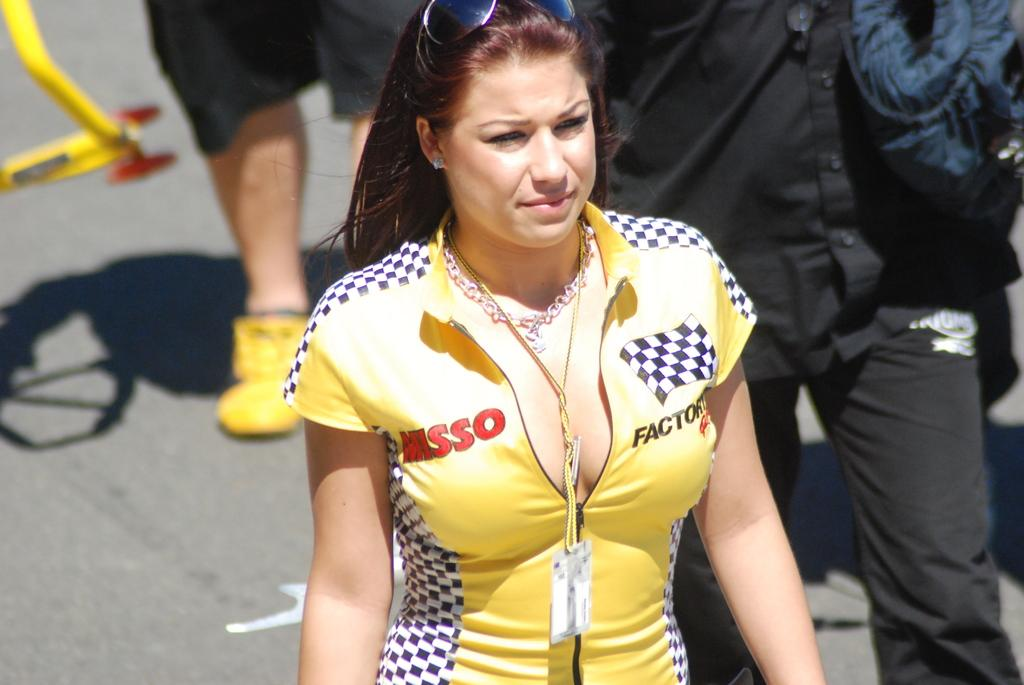Provide a one-sentence caption for the provided image. A woman is wearing a shirt that says MISSO on it. 